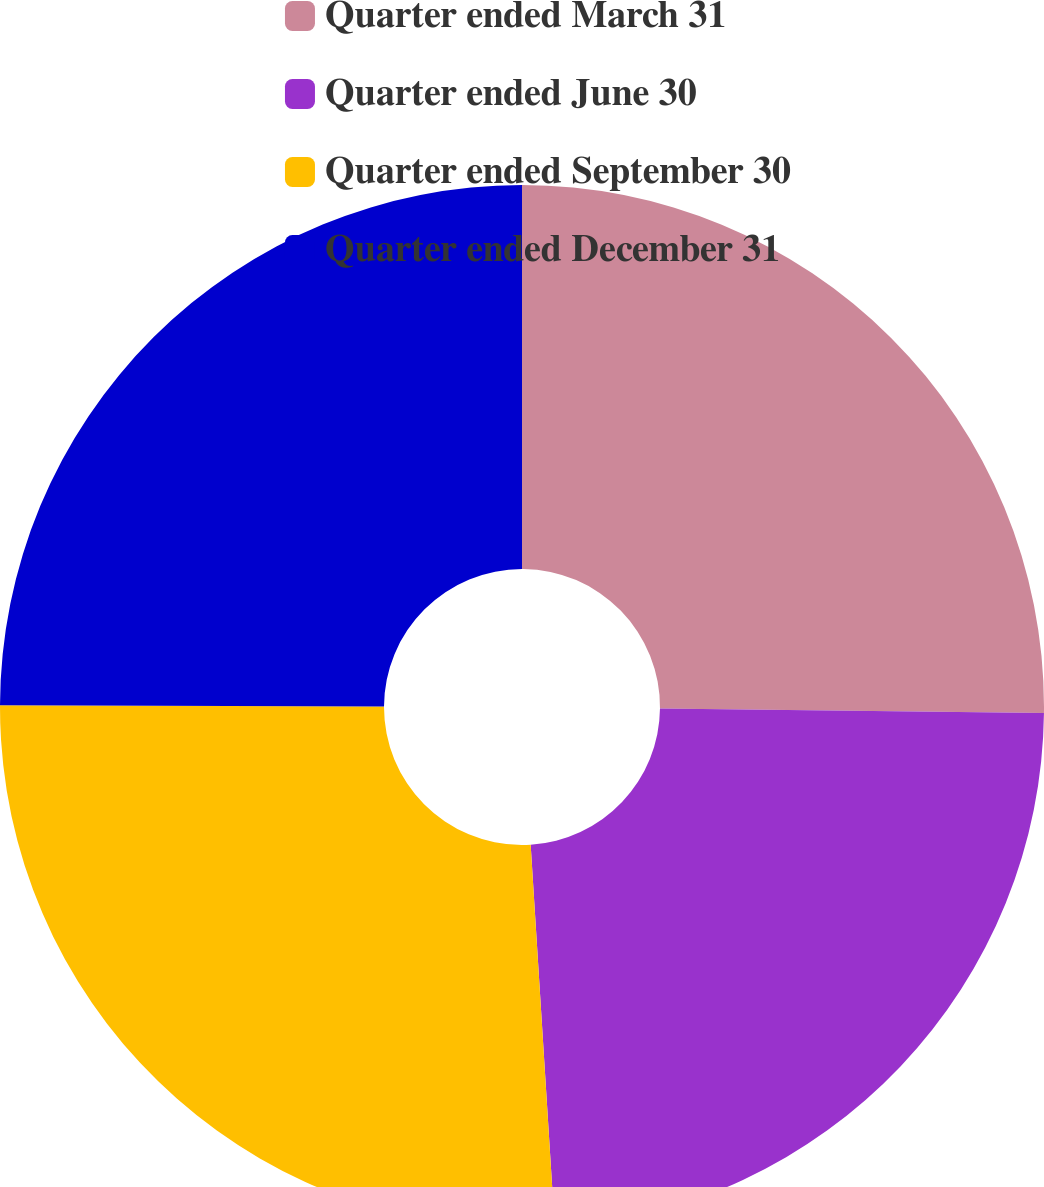<chart> <loc_0><loc_0><loc_500><loc_500><pie_chart><fcel>Quarter ended March 31<fcel>Quarter ended June 30<fcel>Quarter ended September 30<fcel>Quarter ended December 31<nl><fcel>25.18%<fcel>23.82%<fcel>26.05%<fcel>24.95%<nl></chart> 